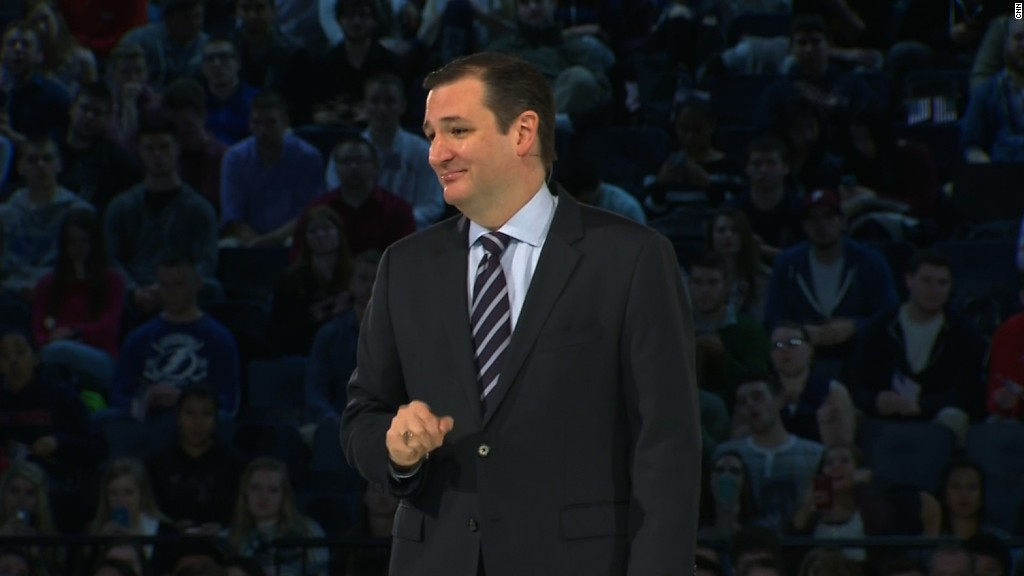Can you describe what the audience's reaction might be based on their body language and expressions? Judging by the body language and expressions of the audience, they appear to be attentive and engaged. Many are looking directly at the speaker, suggesting they are listening intently. The presence of some smiling faces and attentive postures indicates interest and possibly agreement or amusement at something the speaker is saying. The diversity in reactions implies a mix of attentiveness, curiosity, and casual interest. 